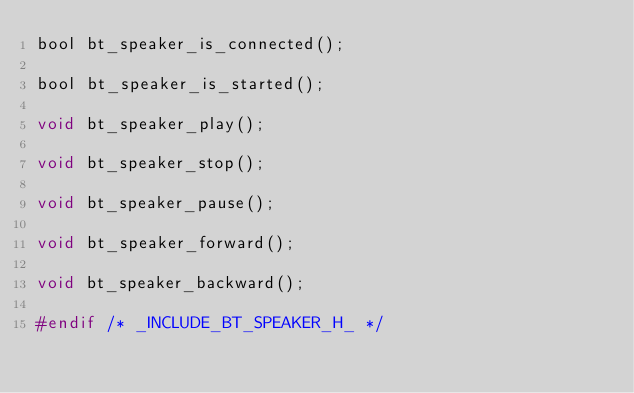Convert code to text. <code><loc_0><loc_0><loc_500><loc_500><_C_>bool bt_speaker_is_connected();

bool bt_speaker_is_started();

void bt_speaker_play();

void bt_speaker_stop();

void bt_speaker_pause();

void bt_speaker_forward();

void bt_speaker_backward();

#endif /* _INCLUDE_BT_SPEAKER_H_ */</code> 